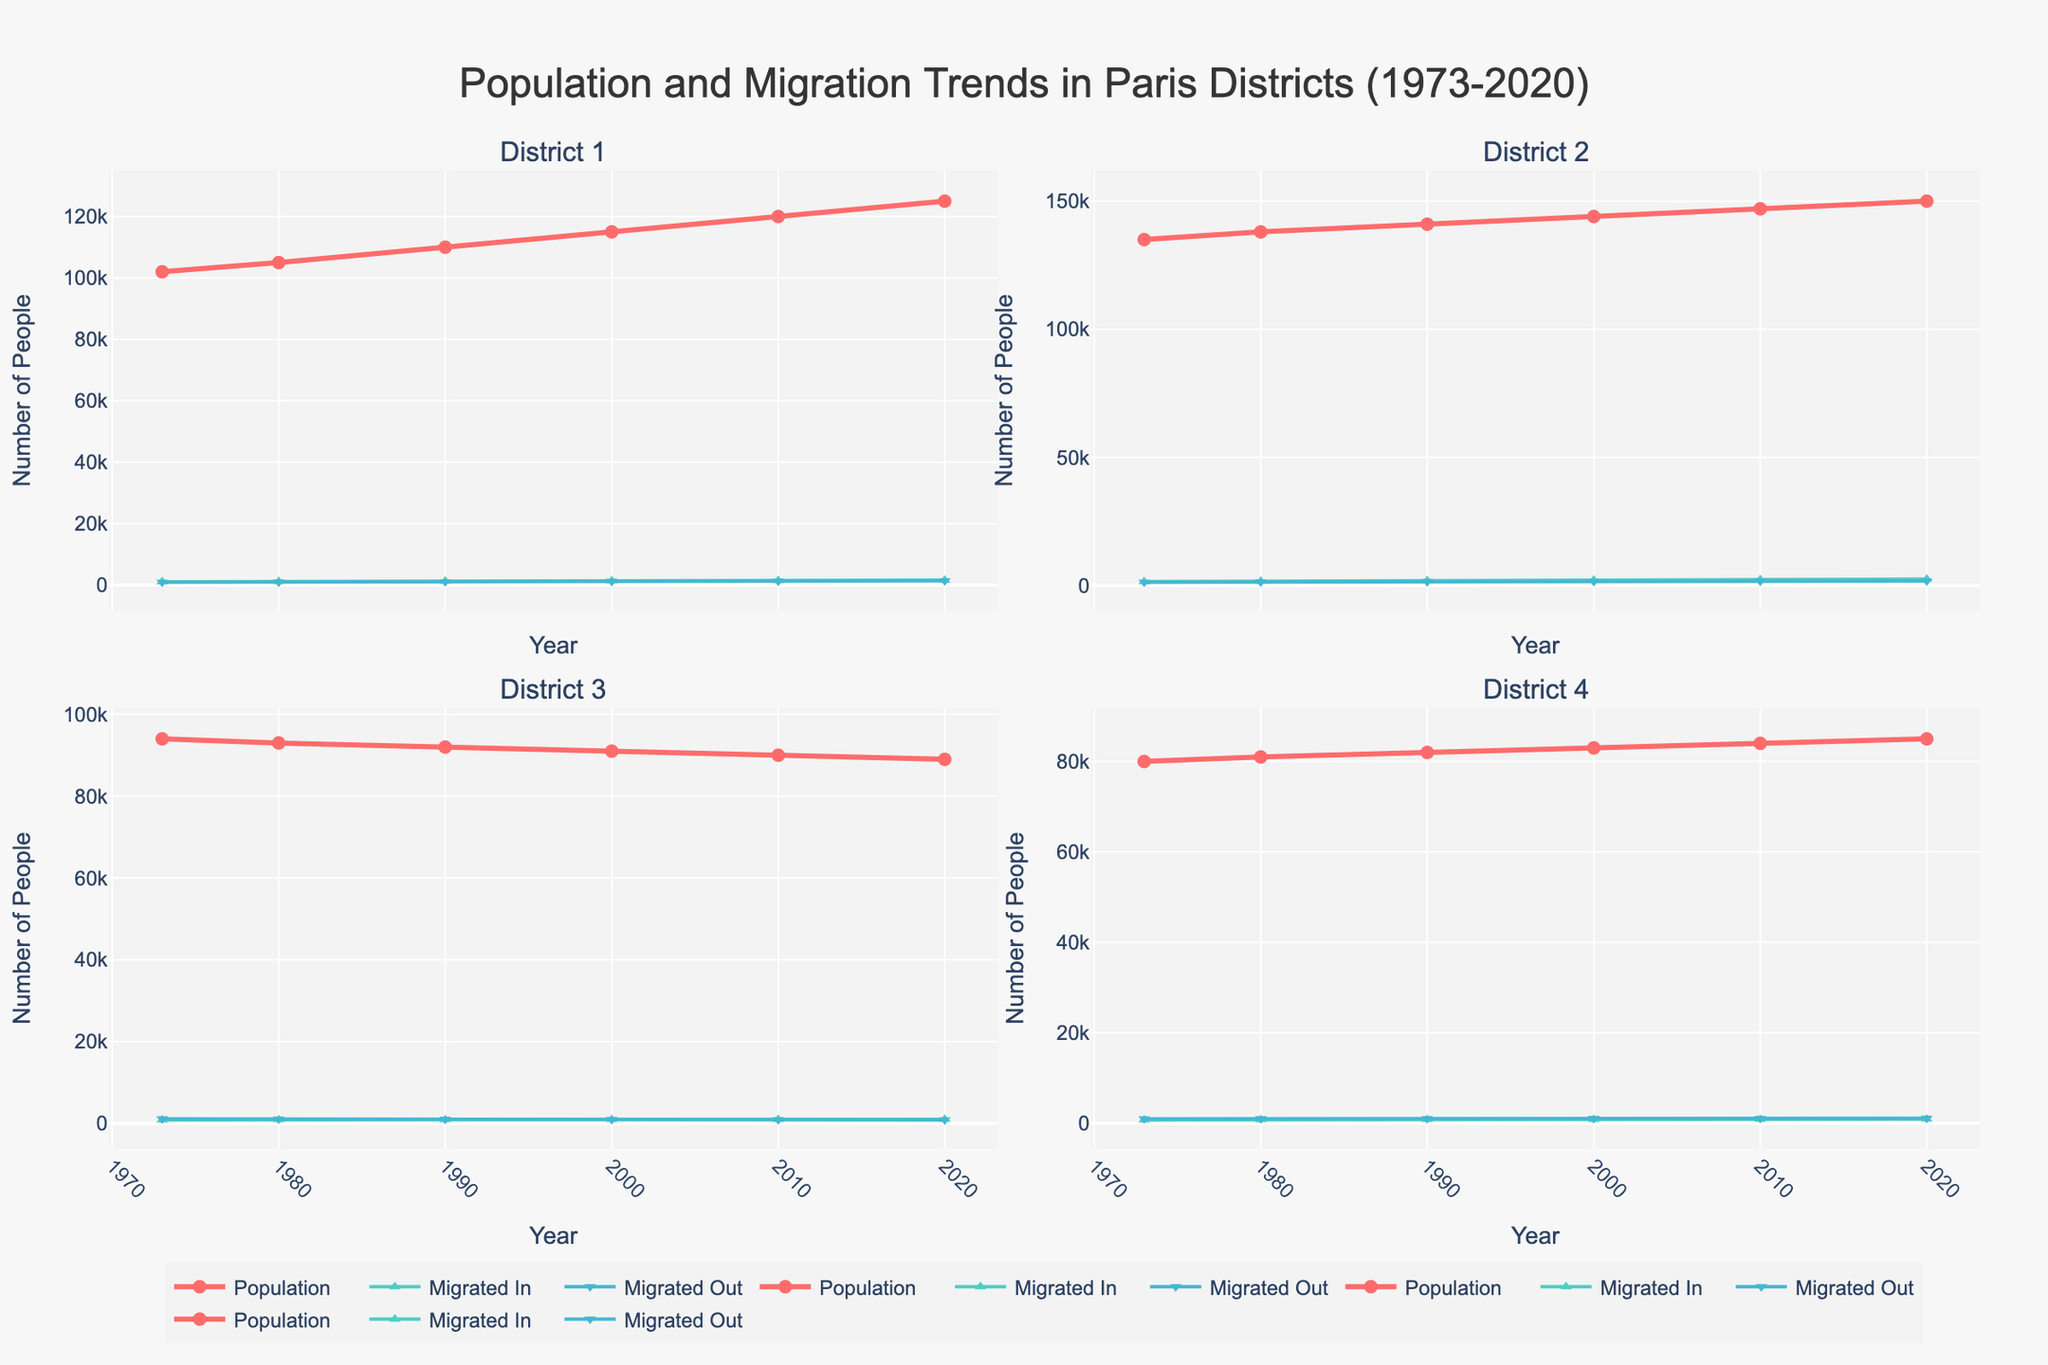How many districts are there in the figure? The subplot titles indicate the number of districts as there are four subplot titles each corresponding to a district.
Answer: 4 What is the overall trend in the population of District 1 from 1973 to 2020? Observing the line representing the population for District 1, it shows an upward trend, starting from 102,000 in 1973 and reaching 125,000 in 2020.
Answer: Increasing In which year did District 2 have a higher number of people migrating in compared to people migrating out? By comparing the 'Migrated In' and 'Migrated Out' lines for District 2, in all the years displayed (1973, 1980, 1990, 2000, 2010, 2020), the 'Migrated In' values are higher than the 'Migrated Out' values.
Answer: All years What is the largest population growth observed for any district between two consecutive years? Observing the population lines for all districts, the largest growth is for District 2 from 147,000 in 2010 to 150,000 in 2020, showing an increase of 3,000.
Answer: 3,000 Which district had the least population in 2020, and what was the population? Observing the population lines in the year 2020, District 3 had the least population at 89,000.
Answer: District 3, 89,000 Did District 4 have more people migrating in or out in 2010? Comparing the 'Migrated In' and 'Migrated Out' markers for District 4 in 2010, there were 830 people who migrated in and 1,030 who migrated out.
Answer: More migrated out How many more people migrated into District 1 in 2020 compared to 1980? The 'Migrated In' value for District 1 in 2020 is 1,600 and in 1980 is 1,200. The difference is 1,600 - 1,200 = 400.
Answer: 400 What was the percentage change in the population of District 4 from 1973 to 1990? The population in 1973 was 80,000 and in 1990 was 82,000. The percentage change is [(82,000 - 80,000) / 80,000] * 100 = 2.5%.
Answer: 2.5% Which district showed a declining population trend throughout the entire period? Observing the population lines, District 3 starts at 94,000 in 1973 and decreases to 89,000 in 2020, indicating a consistent decline.
Answer: District 3 What is the combined total population of all districts in 1990? Summing up the population of all districts in 1990: 110,000 (District 1) + 141,000 (District 2) + 92,000 (District 3) + 82,000 (District 4) = 425,000.
Answer: 425,000 